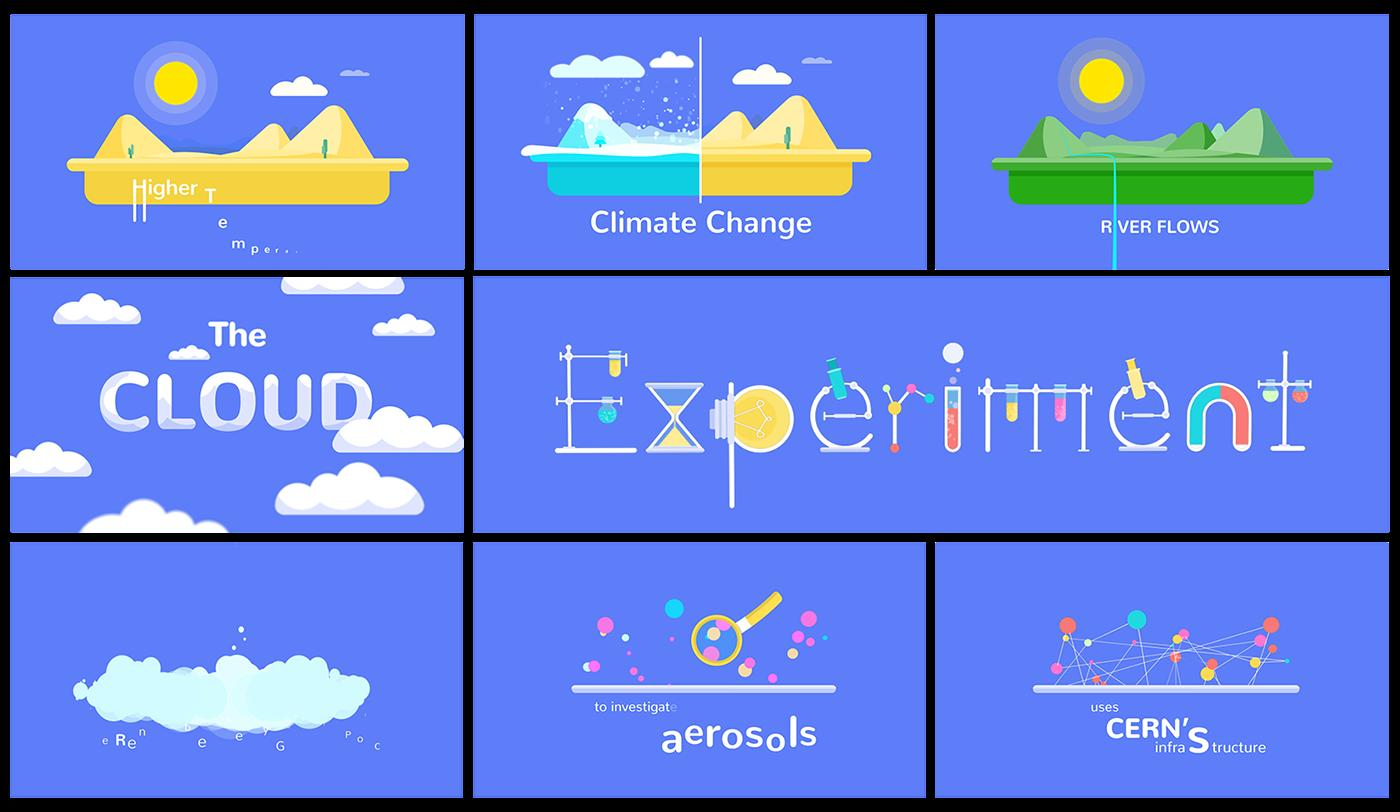Mention a couple of crucial points in this snapshot. The color of ice in the context of climate change is typically blue, indicating the presence of water and its melting due to global warming. Test tubes and light bulbs are commonly used in experiments. 